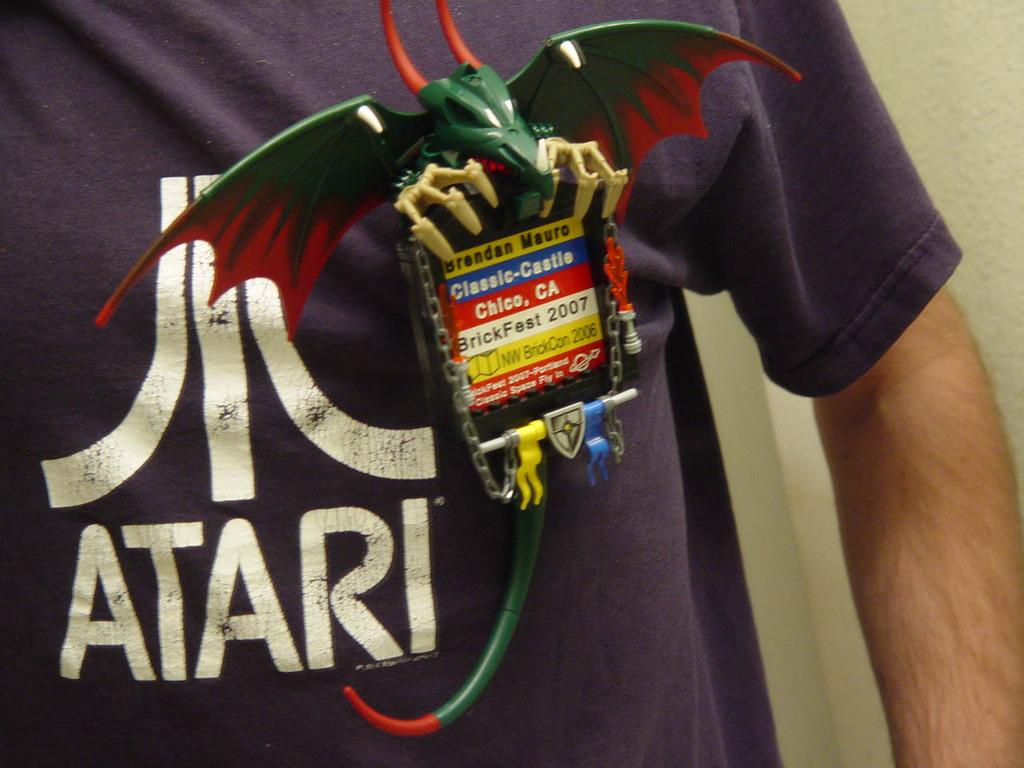<image>
Offer a succinct explanation of the picture presented. A person in an Atari t-shirt shows off a dragon shaped badge. 